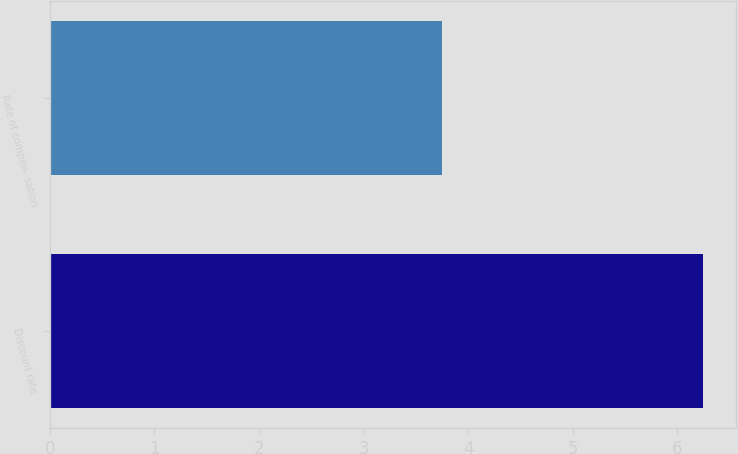Convert chart to OTSL. <chart><loc_0><loc_0><loc_500><loc_500><bar_chart><fcel>Discount rate<fcel>Rate of compen- sation<nl><fcel>6.25<fcel>3.75<nl></chart> 